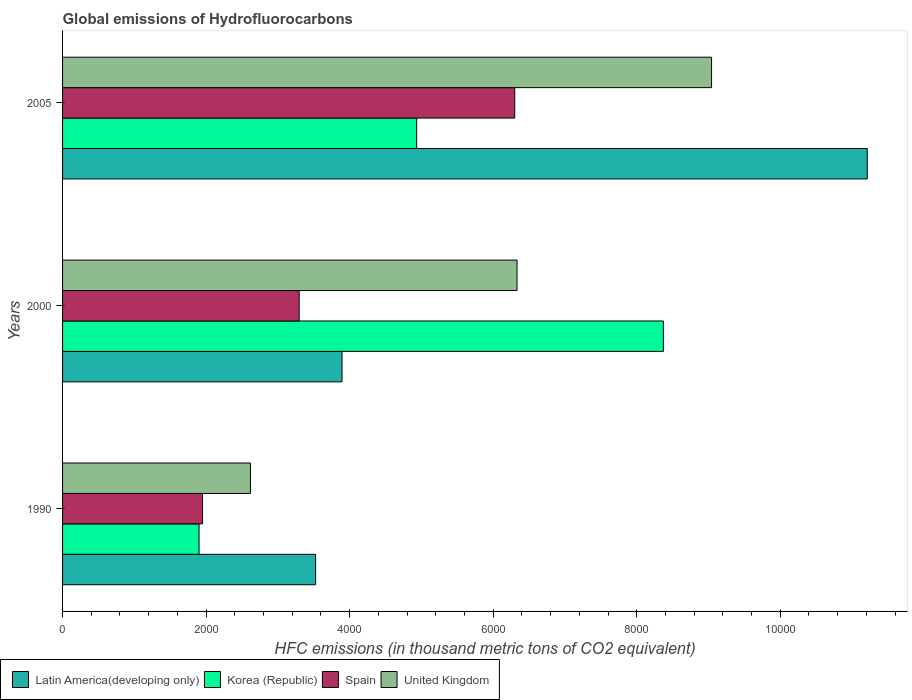How many groups of bars are there?
Give a very brief answer. 3. Are the number of bars per tick equal to the number of legend labels?
Your answer should be very brief. Yes. Are the number of bars on each tick of the Y-axis equal?
Your response must be concise. Yes. How many bars are there on the 1st tick from the top?
Offer a very short reply. 4. What is the label of the 1st group of bars from the top?
Your answer should be very brief. 2005. What is the global emissions of Hydrofluorocarbons in United Kingdom in 2005?
Ensure brevity in your answer.  9043.4. Across all years, what is the maximum global emissions of Hydrofluorocarbons in United Kingdom?
Your answer should be very brief. 9043.4. Across all years, what is the minimum global emissions of Hydrofluorocarbons in Korea (Republic)?
Give a very brief answer. 1901.7. In which year was the global emissions of Hydrofluorocarbons in Korea (Republic) maximum?
Your response must be concise. 2000. What is the total global emissions of Hydrofluorocarbons in Spain in the graph?
Provide a succinct answer. 1.15e+04. What is the difference between the global emissions of Hydrofluorocarbons in Spain in 1990 and that in 2000?
Provide a succinct answer. -1346.5. What is the difference between the global emissions of Hydrofluorocarbons in Latin America(developing only) in 1990 and the global emissions of Hydrofluorocarbons in Korea (Republic) in 2000?
Make the answer very short. -4845.8. What is the average global emissions of Hydrofluorocarbons in United Kingdom per year?
Give a very brief answer. 5997.9. In the year 2005, what is the difference between the global emissions of Hydrofluorocarbons in Latin America(developing only) and global emissions of Hydrofluorocarbons in United Kingdom?
Give a very brief answer. 2169.16. What is the ratio of the global emissions of Hydrofluorocarbons in Latin America(developing only) in 1990 to that in 2000?
Provide a succinct answer. 0.91. Is the global emissions of Hydrofluorocarbons in Latin America(developing only) in 1990 less than that in 2005?
Your answer should be compact. Yes. Is the difference between the global emissions of Hydrofluorocarbons in Latin America(developing only) in 2000 and 2005 greater than the difference between the global emissions of Hydrofluorocarbons in United Kingdom in 2000 and 2005?
Provide a short and direct response. No. What is the difference between the highest and the second highest global emissions of Hydrofluorocarbons in Spain?
Give a very brief answer. 3003.5. What is the difference between the highest and the lowest global emissions of Hydrofluorocarbons in Korea (Republic)?
Your response must be concise. 6470.2. In how many years, is the global emissions of Hydrofluorocarbons in United Kingdom greater than the average global emissions of Hydrofluorocarbons in United Kingdom taken over all years?
Offer a terse response. 2. Is it the case that in every year, the sum of the global emissions of Hydrofluorocarbons in Spain and global emissions of Hydrofluorocarbons in United Kingdom is greater than the sum of global emissions of Hydrofluorocarbons in Korea (Republic) and global emissions of Hydrofluorocarbons in Latin America(developing only)?
Ensure brevity in your answer.  No. What does the 3rd bar from the bottom in 2000 represents?
Offer a terse response. Spain. Is it the case that in every year, the sum of the global emissions of Hydrofluorocarbons in Korea (Republic) and global emissions of Hydrofluorocarbons in United Kingdom is greater than the global emissions of Hydrofluorocarbons in Spain?
Offer a terse response. Yes. How many bars are there?
Your answer should be compact. 12. What is the title of the graph?
Your response must be concise. Global emissions of Hydrofluorocarbons. What is the label or title of the X-axis?
Ensure brevity in your answer.  HFC emissions (in thousand metric tons of CO2 equivalent). What is the label or title of the Y-axis?
Offer a terse response. Years. What is the HFC emissions (in thousand metric tons of CO2 equivalent) in Latin America(developing only) in 1990?
Your response must be concise. 3526.1. What is the HFC emissions (in thousand metric tons of CO2 equivalent) in Korea (Republic) in 1990?
Offer a terse response. 1901.7. What is the HFC emissions (in thousand metric tons of CO2 equivalent) in Spain in 1990?
Ensure brevity in your answer.  1950.3. What is the HFC emissions (in thousand metric tons of CO2 equivalent) in United Kingdom in 1990?
Your response must be concise. 2617.8. What is the HFC emissions (in thousand metric tons of CO2 equivalent) in Latin America(developing only) in 2000?
Give a very brief answer. 3893.7. What is the HFC emissions (in thousand metric tons of CO2 equivalent) in Korea (Republic) in 2000?
Give a very brief answer. 8371.9. What is the HFC emissions (in thousand metric tons of CO2 equivalent) of Spain in 2000?
Offer a terse response. 3296.8. What is the HFC emissions (in thousand metric tons of CO2 equivalent) of United Kingdom in 2000?
Your answer should be very brief. 6332.5. What is the HFC emissions (in thousand metric tons of CO2 equivalent) in Latin America(developing only) in 2005?
Ensure brevity in your answer.  1.12e+04. What is the HFC emissions (in thousand metric tons of CO2 equivalent) in Korea (Republic) in 2005?
Make the answer very short. 4933.9. What is the HFC emissions (in thousand metric tons of CO2 equivalent) in Spain in 2005?
Make the answer very short. 6300.3. What is the HFC emissions (in thousand metric tons of CO2 equivalent) of United Kingdom in 2005?
Ensure brevity in your answer.  9043.4. Across all years, what is the maximum HFC emissions (in thousand metric tons of CO2 equivalent) of Latin America(developing only)?
Give a very brief answer. 1.12e+04. Across all years, what is the maximum HFC emissions (in thousand metric tons of CO2 equivalent) of Korea (Republic)?
Ensure brevity in your answer.  8371.9. Across all years, what is the maximum HFC emissions (in thousand metric tons of CO2 equivalent) of Spain?
Offer a terse response. 6300.3. Across all years, what is the maximum HFC emissions (in thousand metric tons of CO2 equivalent) of United Kingdom?
Keep it short and to the point. 9043.4. Across all years, what is the minimum HFC emissions (in thousand metric tons of CO2 equivalent) in Latin America(developing only)?
Give a very brief answer. 3526.1. Across all years, what is the minimum HFC emissions (in thousand metric tons of CO2 equivalent) of Korea (Republic)?
Provide a short and direct response. 1901.7. Across all years, what is the minimum HFC emissions (in thousand metric tons of CO2 equivalent) in Spain?
Your answer should be compact. 1950.3. Across all years, what is the minimum HFC emissions (in thousand metric tons of CO2 equivalent) of United Kingdom?
Give a very brief answer. 2617.8. What is the total HFC emissions (in thousand metric tons of CO2 equivalent) of Latin America(developing only) in the graph?
Ensure brevity in your answer.  1.86e+04. What is the total HFC emissions (in thousand metric tons of CO2 equivalent) of Korea (Republic) in the graph?
Your response must be concise. 1.52e+04. What is the total HFC emissions (in thousand metric tons of CO2 equivalent) of Spain in the graph?
Offer a terse response. 1.15e+04. What is the total HFC emissions (in thousand metric tons of CO2 equivalent) of United Kingdom in the graph?
Make the answer very short. 1.80e+04. What is the difference between the HFC emissions (in thousand metric tons of CO2 equivalent) of Latin America(developing only) in 1990 and that in 2000?
Make the answer very short. -367.6. What is the difference between the HFC emissions (in thousand metric tons of CO2 equivalent) of Korea (Republic) in 1990 and that in 2000?
Ensure brevity in your answer.  -6470.2. What is the difference between the HFC emissions (in thousand metric tons of CO2 equivalent) of Spain in 1990 and that in 2000?
Make the answer very short. -1346.5. What is the difference between the HFC emissions (in thousand metric tons of CO2 equivalent) in United Kingdom in 1990 and that in 2000?
Offer a very short reply. -3714.7. What is the difference between the HFC emissions (in thousand metric tons of CO2 equivalent) in Latin America(developing only) in 1990 and that in 2005?
Your response must be concise. -7686.46. What is the difference between the HFC emissions (in thousand metric tons of CO2 equivalent) of Korea (Republic) in 1990 and that in 2005?
Your response must be concise. -3032.2. What is the difference between the HFC emissions (in thousand metric tons of CO2 equivalent) of Spain in 1990 and that in 2005?
Offer a terse response. -4350. What is the difference between the HFC emissions (in thousand metric tons of CO2 equivalent) of United Kingdom in 1990 and that in 2005?
Provide a short and direct response. -6425.6. What is the difference between the HFC emissions (in thousand metric tons of CO2 equivalent) of Latin America(developing only) in 2000 and that in 2005?
Offer a terse response. -7318.86. What is the difference between the HFC emissions (in thousand metric tons of CO2 equivalent) of Korea (Republic) in 2000 and that in 2005?
Ensure brevity in your answer.  3438. What is the difference between the HFC emissions (in thousand metric tons of CO2 equivalent) in Spain in 2000 and that in 2005?
Give a very brief answer. -3003.5. What is the difference between the HFC emissions (in thousand metric tons of CO2 equivalent) in United Kingdom in 2000 and that in 2005?
Provide a short and direct response. -2710.9. What is the difference between the HFC emissions (in thousand metric tons of CO2 equivalent) in Latin America(developing only) in 1990 and the HFC emissions (in thousand metric tons of CO2 equivalent) in Korea (Republic) in 2000?
Your response must be concise. -4845.8. What is the difference between the HFC emissions (in thousand metric tons of CO2 equivalent) in Latin America(developing only) in 1990 and the HFC emissions (in thousand metric tons of CO2 equivalent) in Spain in 2000?
Offer a terse response. 229.3. What is the difference between the HFC emissions (in thousand metric tons of CO2 equivalent) of Latin America(developing only) in 1990 and the HFC emissions (in thousand metric tons of CO2 equivalent) of United Kingdom in 2000?
Your answer should be compact. -2806.4. What is the difference between the HFC emissions (in thousand metric tons of CO2 equivalent) of Korea (Republic) in 1990 and the HFC emissions (in thousand metric tons of CO2 equivalent) of Spain in 2000?
Your response must be concise. -1395.1. What is the difference between the HFC emissions (in thousand metric tons of CO2 equivalent) in Korea (Republic) in 1990 and the HFC emissions (in thousand metric tons of CO2 equivalent) in United Kingdom in 2000?
Give a very brief answer. -4430.8. What is the difference between the HFC emissions (in thousand metric tons of CO2 equivalent) in Spain in 1990 and the HFC emissions (in thousand metric tons of CO2 equivalent) in United Kingdom in 2000?
Your response must be concise. -4382.2. What is the difference between the HFC emissions (in thousand metric tons of CO2 equivalent) of Latin America(developing only) in 1990 and the HFC emissions (in thousand metric tons of CO2 equivalent) of Korea (Republic) in 2005?
Offer a terse response. -1407.8. What is the difference between the HFC emissions (in thousand metric tons of CO2 equivalent) of Latin America(developing only) in 1990 and the HFC emissions (in thousand metric tons of CO2 equivalent) of Spain in 2005?
Offer a terse response. -2774.2. What is the difference between the HFC emissions (in thousand metric tons of CO2 equivalent) in Latin America(developing only) in 1990 and the HFC emissions (in thousand metric tons of CO2 equivalent) in United Kingdom in 2005?
Keep it short and to the point. -5517.3. What is the difference between the HFC emissions (in thousand metric tons of CO2 equivalent) of Korea (Republic) in 1990 and the HFC emissions (in thousand metric tons of CO2 equivalent) of Spain in 2005?
Keep it short and to the point. -4398.6. What is the difference between the HFC emissions (in thousand metric tons of CO2 equivalent) in Korea (Republic) in 1990 and the HFC emissions (in thousand metric tons of CO2 equivalent) in United Kingdom in 2005?
Your response must be concise. -7141.7. What is the difference between the HFC emissions (in thousand metric tons of CO2 equivalent) in Spain in 1990 and the HFC emissions (in thousand metric tons of CO2 equivalent) in United Kingdom in 2005?
Keep it short and to the point. -7093.1. What is the difference between the HFC emissions (in thousand metric tons of CO2 equivalent) in Latin America(developing only) in 2000 and the HFC emissions (in thousand metric tons of CO2 equivalent) in Korea (Republic) in 2005?
Offer a very short reply. -1040.2. What is the difference between the HFC emissions (in thousand metric tons of CO2 equivalent) of Latin America(developing only) in 2000 and the HFC emissions (in thousand metric tons of CO2 equivalent) of Spain in 2005?
Your answer should be compact. -2406.6. What is the difference between the HFC emissions (in thousand metric tons of CO2 equivalent) of Latin America(developing only) in 2000 and the HFC emissions (in thousand metric tons of CO2 equivalent) of United Kingdom in 2005?
Offer a terse response. -5149.7. What is the difference between the HFC emissions (in thousand metric tons of CO2 equivalent) in Korea (Republic) in 2000 and the HFC emissions (in thousand metric tons of CO2 equivalent) in Spain in 2005?
Give a very brief answer. 2071.6. What is the difference between the HFC emissions (in thousand metric tons of CO2 equivalent) in Korea (Republic) in 2000 and the HFC emissions (in thousand metric tons of CO2 equivalent) in United Kingdom in 2005?
Keep it short and to the point. -671.5. What is the difference between the HFC emissions (in thousand metric tons of CO2 equivalent) of Spain in 2000 and the HFC emissions (in thousand metric tons of CO2 equivalent) of United Kingdom in 2005?
Your response must be concise. -5746.6. What is the average HFC emissions (in thousand metric tons of CO2 equivalent) in Latin America(developing only) per year?
Your response must be concise. 6210.79. What is the average HFC emissions (in thousand metric tons of CO2 equivalent) in Korea (Republic) per year?
Ensure brevity in your answer.  5069.17. What is the average HFC emissions (in thousand metric tons of CO2 equivalent) of Spain per year?
Your response must be concise. 3849.13. What is the average HFC emissions (in thousand metric tons of CO2 equivalent) of United Kingdom per year?
Your response must be concise. 5997.9. In the year 1990, what is the difference between the HFC emissions (in thousand metric tons of CO2 equivalent) of Latin America(developing only) and HFC emissions (in thousand metric tons of CO2 equivalent) of Korea (Republic)?
Ensure brevity in your answer.  1624.4. In the year 1990, what is the difference between the HFC emissions (in thousand metric tons of CO2 equivalent) in Latin America(developing only) and HFC emissions (in thousand metric tons of CO2 equivalent) in Spain?
Offer a very short reply. 1575.8. In the year 1990, what is the difference between the HFC emissions (in thousand metric tons of CO2 equivalent) of Latin America(developing only) and HFC emissions (in thousand metric tons of CO2 equivalent) of United Kingdom?
Keep it short and to the point. 908.3. In the year 1990, what is the difference between the HFC emissions (in thousand metric tons of CO2 equivalent) in Korea (Republic) and HFC emissions (in thousand metric tons of CO2 equivalent) in Spain?
Offer a terse response. -48.6. In the year 1990, what is the difference between the HFC emissions (in thousand metric tons of CO2 equivalent) of Korea (Republic) and HFC emissions (in thousand metric tons of CO2 equivalent) of United Kingdom?
Offer a terse response. -716.1. In the year 1990, what is the difference between the HFC emissions (in thousand metric tons of CO2 equivalent) of Spain and HFC emissions (in thousand metric tons of CO2 equivalent) of United Kingdom?
Offer a terse response. -667.5. In the year 2000, what is the difference between the HFC emissions (in thousand metric tons of CO2 equivalent) of Latin America(developing only) and HFC emissions (in thousand metric tons of CO2 equivalent) of Korea (Republic)?
Provide a short and direct response. -4478.2. In the year 2000, what is the difference between the HFC emissions (in thousand metric tons of CO2 equivalent) in Latin America(developing only) and HFC emissions (in thousand metric tons of CO2 equivalent) in Spain?
Provide a succinct answer. 596.9. In the year 2000, what is the difference between the HFC emissions (in thousand metric tons of CO2 equivalent) in Latin America(developing only) and HFC emissions (in thousand metric tons of CO2 equivalent) in United Kingdom?
Offer a very short reply. -2438.8. In the year 2000, what is the difference between the HFC emissions (in thousand metric tons of CO2 equivalent) of Korea (Republic) and HFC emissions (in thousand metric tons of CO2 equivalent) of Spain?
Your answer should be compact. 5075.1. In the year 2000, what is the difference between the HFC emissions (in thousand metric tons of CO2 equivalent) in Korea (Republic) and HFC emissions (in thousand metric tons of CO2 equivalent) in United Kingdom?
Offer a terse response. 2039.4. In the year 2000, what is the difference between the HFC emissions (in thousand metric tons of CO2 equivalent) in Spain and HFC emissions (in thousand metric tons of CO2 equivalent) in United Kingdom?
Provide a short and direct response. -3035.7. In the year 2005, what is the difference between the HFC emissions (in thousand metric tons of CO2 equivalent) of Latin America(developing only) and HFC emissions (in thousand metric tons of CO2 equivalent) of Korea (Republic)?
Make the answer very short. 6278.66. In the year 2005, what is the difference between the HFC emissions (in thousand metric tons of CO2 equivalent) of Latin America(developing only) and HFC emissions (in thousand metric tons of CO2 equivalent) of Spain?
Ensure brevity in your answer.  4912.26. In the year 2005, what is the difference between the HFC emissions (in thousand metric tons of CO2 equivalent) of Latin America(developing only) and HFC emissions (in thousand metric tons of CO2 equivalent) of United Kingdom?
Your answer should be compact. 2169.16. In the year 2005, what is the difference between the HFC emissions (in thousand metric tons of CO2 equivalent) of Korea (Republic) and HFC emissions (in thousand metric tons of CO2 equivalent) of Spain?
Offer a very short reply. -1366.4. In the year 2005, what is the difference between the HFC emissions (in thousand metric tons of CO2 equivalent) in Korea (Republic) and HFC emissions (in thousand metric tons of CO2 equivalent) in United Kingdom?
Offer a terse response. -4109.5. In the year 2005, what is the difference between the HFC emissions (in thousand metric tons of CO2 equivalent) of Spain and HFC emissions (in thousand metric tons of CO2 equivalent) of United Kingdom?
Your response must be concise. -2743.1. What is the ratio of the HFC emissions (in thousand metric tons of CO2 equivalent) of Latin America(developing only) in 1990 to that in 2000?
Offer a very short reply. 0.91. What is the ratio of the HFC emissions (in thousand metric tons of CO2 equivalent) of Korea (Republic) in 1990 to that in 2000?
Provide a short and direct response. 0.23. What is the ratio of the HFC emissions (in thousand metric tons of CO2 equivalent) in Spain in 1990 to that in 2000?
Offer a terse response. 0.59. What is the ratio of the HFC emissions (in thousand metric tons of CO2 equivalent) in United Kingdom in 1990 to that in 2000?
Ensure brevity in your answer.  0.41. What is the ratio of the HFC emissions (in thousand metric tons of CO2 equivalent) of Latin America(developing only) in 1990 to that in 2005?
Offer a terse response. 0.31. What is the ratio of the HFC emissions (in thousand metric tons of CO2 equivalent) of Korea (Republic) in 1990 to that in 2005?
Provide a succinct answer. 0.39. What is the ratio of the HFC emissions (in thousand metric tons of CO2 equivalent) of Spain in 1990 to that in 2005?
Provide a short and direct response. 0.31. What is the ratio of the HFC emissions (in thousand metric tons of CO2 equivalent) of United Kingdom in 1990 to that in 2005?
Offer a very short reply. 0.29. What is the ratio of the HFC emissions (in thousand metric tons of CO2 equivalent) in Latin America(developing only) in 2000 to that in 2005?
Keep it short and to the point. 0.35. What is the ratio of the HFC emissions (in thousand metric tons of CO2 equivalent) in Korea (Republic) in 2000 to that in 2005?
Give a very brief answer. 1.7. What is the ratio of the HFC emissions (in thousand metric tons of CO2 equivalent) in Spain in 2000 to that in 2005?
Keep it short and to the point. 0.52. What is the ratio of the HFC emissions (in thousand metric tons of CO2 equivalent) in United Kingdom in 2000 to that in 2005?
Give a very brief answer. 0.7. What is the difference between the highest and the second highest HFC emissions (in thousand metric tons of CO2 equivalent) in Latin America(developing only)?
Offer a very short reply. 7318.86. What is the difference between the highest and the second highest HFC emissions (in thousand metric tons of CO2 equivalent) of Korea (Republic)?
Offer a very short reply. 3438. What is the difference between the highest and the second highest HFC emissions (in thousand metric tons of CO2 equivalent) in Spain?
Your response must be concise. 3003.5. What is the difference between the highest and the second highest HFC emissions (in thousand metric tons of CO2 equivalent) in United Kingdom?
Make the answer very short. 2710.9. What is the difference between the highest and the lowest HFC emissions (in thousand metric tons of CO2 equivalent) of Latin America(developing only)?
Your response must be concise. 7686.46. What is the difference between the highest and the lowest HFC emissions (in thousand metric tons of CO2 equivalent) of Korea (Republic)?
Your answer should be very brief. 6470.2. What is the difference between the highest and the lowest HFC emissions (in thousand metric tons of CO2 equivalent) of Spain?
Provide a short and direct response. 4350. What is the difference between the highest and the lowest HFC emissions (in thousand metric tons of CO2 equivalent) in United Kingdom?
Give a very brief answer. 6425.6. 